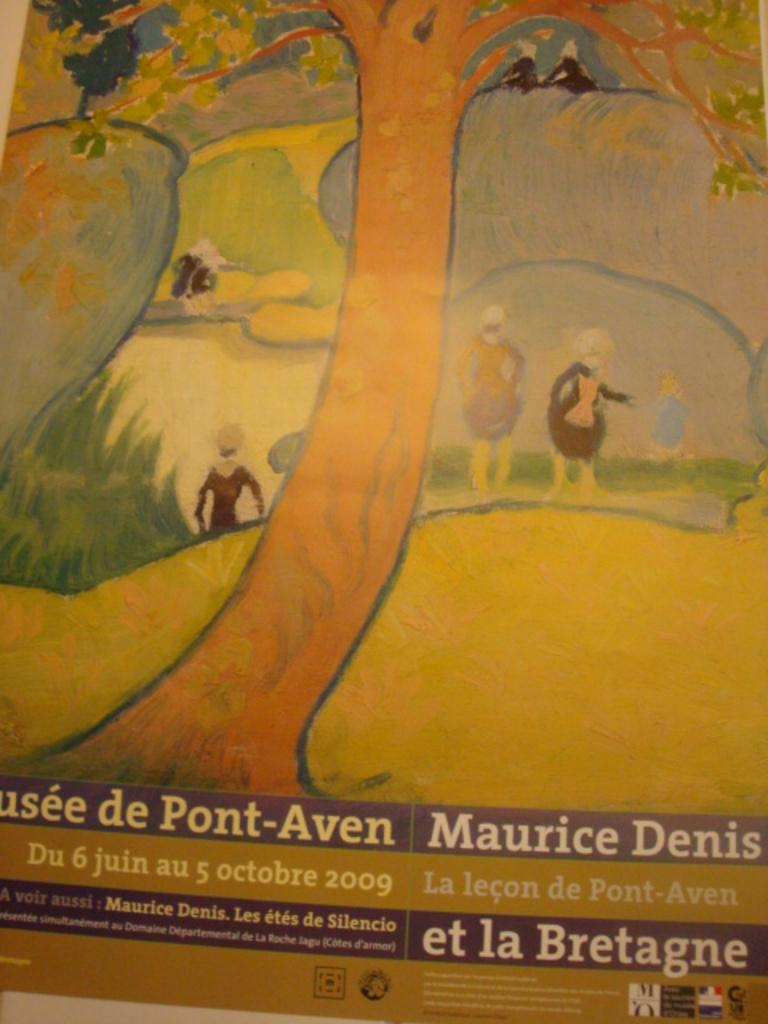<image>
Describe the image concisely. Book cover showing a treet by Maurice Denis. 